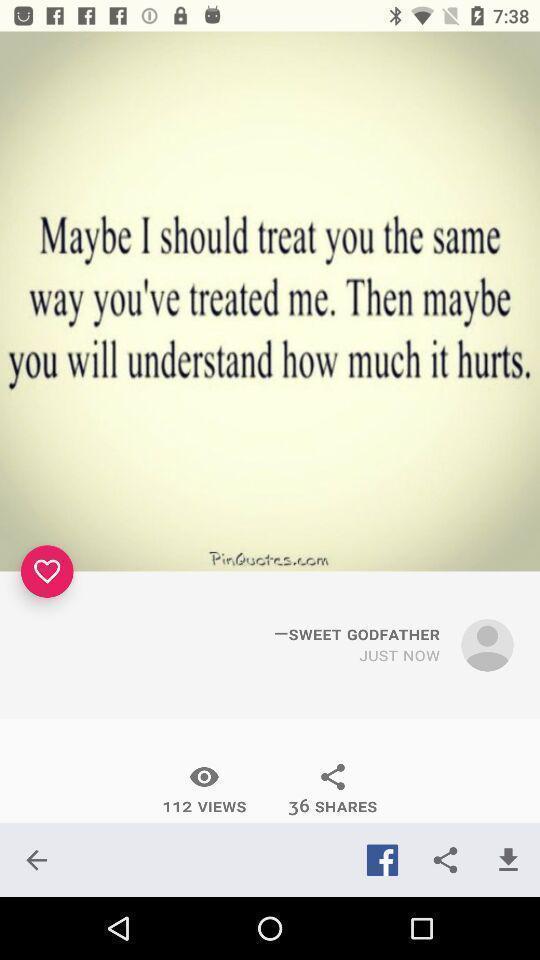Describe the key features of this screenshot. Screen showing quote in social app. 